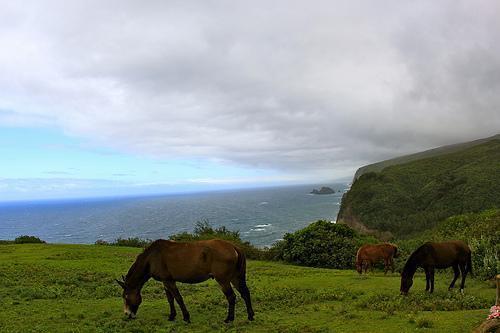How many donkeys are there?
Give a very brief answer. 3. 